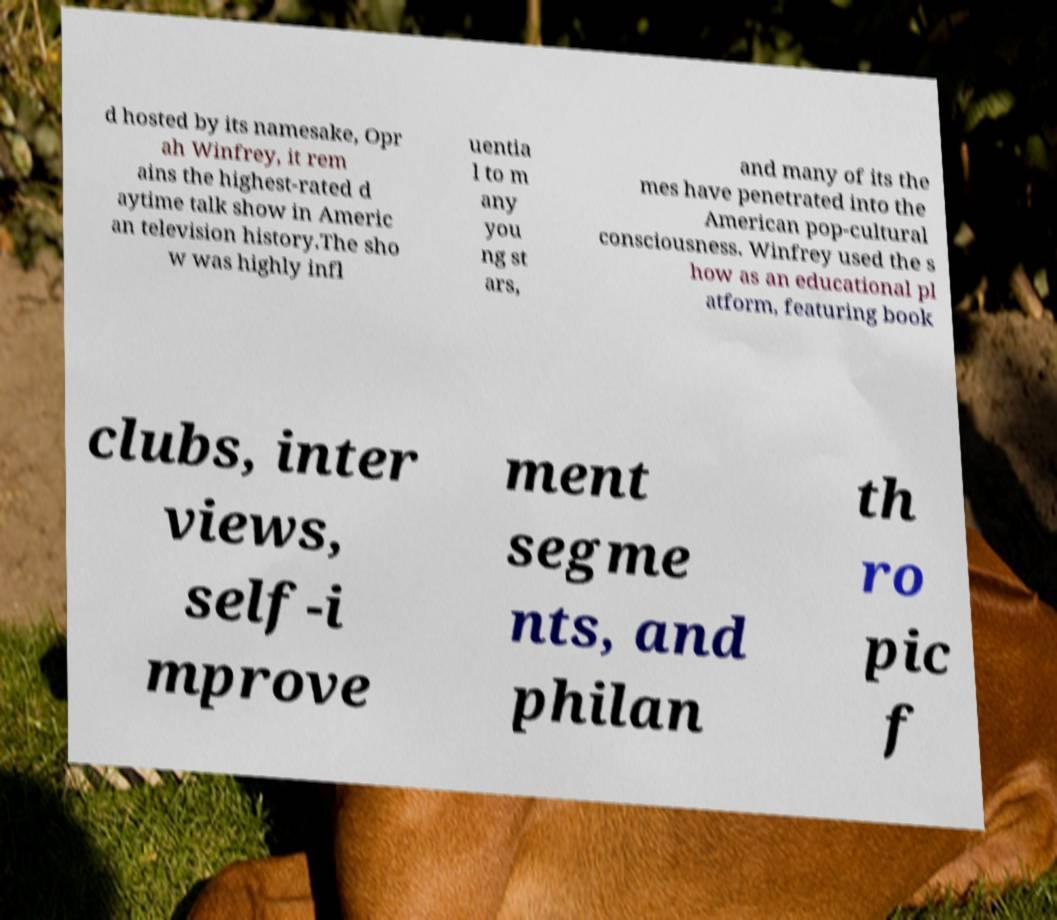What messages or text are displayed in this image? I need them in a readable, typed format. d hosted by its namesake, Opr ah Winfrey, it rem ains the highest-rated d aytime talk show in Americ an television history.The sho w was highly infl uentia l to m any you ng st ars, and many of its the mes have penetrated into the American pop-cultural consciousness. Winfrey used the s how as an educational pl atform, featuring book clubs, inter views, self-i mprove ment segme nts, and philan th ro pic f 